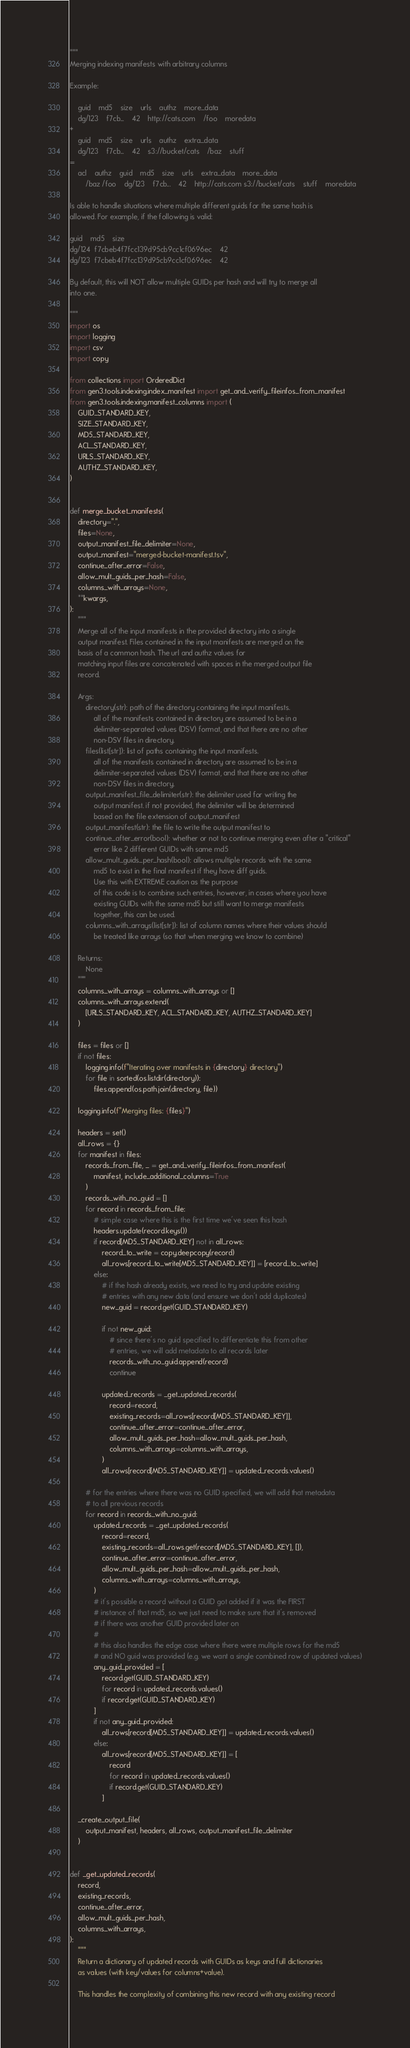<code> <loc_0><loc_0><loc_500><loc_500><_Python_>"""
Merging indexing manifests with arbitrary columns

Example:

    guid    md5    size    urls    authz    more_data
    dg/123    f7cb...    42    http://cats.com    /foo    moredata
+
    guid    md5    size    urls    authz    extra_data
    dg/123    f7cb...    42    s3://bucket/cats    /baz    stuff
=
    acl    authz    guid    md5    size    urls    extra_data    more_data
        /baz /foo    dg/123    f7cb...    42    http://cats.com s3://bucket/cats    stuff    moredata

Is able to handle situations where multiple different guids for the same hash is
allowed. For example, if the following is valid:

guid    md5    size
dg/124  f7cbeb4f7fcc139d95cb9cc1cf0696ec    42
dg/123  f7cbeb4f7fcc139d95cb9cc1cf0696ec    42

By default, this will NOT allow multiple GUIDs per hash and will try to merge all
into one.

"""
import os
import logging
import csv
import copy

from collections import OrderedDict
from gen3.tools.indexing.index_manifest import get_and_verify_fileinfos_from_manifest
from gen3.tools.indexing.manifest_columns import (
    GUID_STANDARD_KEY,
    SIZE_STANDARD_KEY,
    MD5_STANDARD_KEY,
    ACL_STANDARD_KEY,
    URLS_STANDARD_KEY,
    AUTHZ_STANDARD_KEY,
)


def merge_bucket_manifests(
    directory=".",
    files=None,
    output_manifest_file_delimiter=None,
    output_manifest="merged-bucket-manifest.tsv",
    continue_after_error=False,
    allow_mult_guids_per_hash=False,
    columns_with_arrays=None,
    **kwargs,
):
    """
    Merge all of the input manifests in the provided directory into a single
    output manifest. Files contained in the input manifests are merged on the
    basis of a common hash. The url and authz values for
    matching input files are concatenated with spaces in the merged output file
    record.

    Args:
        directory(str): path of the directory containing the input manifests.
            all of the manifests contained in directory are assumed to be in a
            delimiter-separated values (DSV) format, and that there are no other
            non-DSV files in directory.
        files(list[str]): list of paths containing the input manifests.
            all of the manifests contained in directory are assumed to be in a
            delimiter-separated values (DSV) format, and that there are no other
            non-DSV files in directory.
        output_manifest_file_delimiter(str): the delimiter used for writing the
            output manifest. if not provided, the delimiter will be determined
            based on the file extension of output_manifest
        output_manifest(str): the file to write the output manifest to
        continue_after_error(bool): whether or not to continue merging even after a "critical"
            error like 2 different GUIDs with same md5
        allow_mult_guids_per_hash(bool): allows multiple records with the same
            md5 to exist in the final manifest if they have diff guids.
            Use this with EXTREME caution as the purpose
            of this code is to combine such entries, however, in cases where you have
            existing GUIDs with the same md5 but still want to merge manifests
            together, this can be used.
        columns_with_arrays(list[str]): list of column names where their values should
            be treated like arrays (so that when merging we know to combine)

    Returns:
        None
    """
    columns_with_arrays = columns_with_arrays or []
    columns_with_arrays.extend(
        [URLS_STANDARD_KEY, ACL_STANDARD_KEY, AUTHZ_STANDARD_KEY]
    )

    files = files or []
    if not files:
        logging.info(f"Iterating over manifests in {directory} directory")
        for file in sorted(os.listdir(directory)):
            files.append(os.path.join(directory, file))

    logging.info(f"Merging files: {files}")

    headers = set()
    all_rows = {}
    for manifest in files:
        records_from_file, _ = get_and_verify_fileinfos_from_manifest(
            manifest, include_additional_columns=True
        )
        records_with_no_guid = []
        for record in records_from_file:
            # simple case where this is the first time we've seen this hash
            headers.update(record.keys())
            if record[MD5_STANDARD_KEY] not in all_rows:
                record_to_write = copy.deepcopy(record)
                all_rows[record_to_write[MD5_STANDARD_KEY]] = [record_to_write]
            else:
                # if the hash already exists, we need to try and update existing
                # entries with any new data (and ensure we don't add duplicates)
                new_guid = record.get(GUID_STANDARD_KEY)

                if not new_guid:
                    # since there's no guid specified to differentiate this from other
                    # entries, we will add metadata to all records later
                    records_with_no_guid.append(record)
                    continue

                updated_records = _get_updated_records(
                    record=record,
                    existing_records=all_rows[record[MD5_STANDARD_KEY]],
                    continue_after_error=continue_after_error,
                    allow_mult_guids_per_hash=allow_mult_guids_per_hash,
                    columns_with_arrays=columns_with_arrays,
                )
                all_rows[record[MD5_STANDARD_KEY]] = updated_records.values()

        # for the entries where there was no GUID specified, we will add that metadata
        # to all previous records
        for record in records_with_no_guid:
            updated_records = _get_updated_records(
                record=record,
                existing_records=all_rows.get(record[MD5_STANDARD_KEY], []),
                continue_after_error=continue_after_error,
                allow_mult_guids_per_hash=allow_mult_guids_per_hash,
                columns_with_arrays=columns_with_arrays,
            )
            # it's possible a record without a GUID got added if it was the FIRST
            # instance of that md5, so we just need to make sure that it's removed
            # if there was another GUID provided later on
            #
            # this also handles the edge case where there were multiple rows for the md5
            # and NO guid was provided (e.g. we want a single combined row of updated values)
            any_guid_provided = [
                record.get(GUID_STANDARD_KEY)
                for record in updated_records.values()
                if record.get(GUID_STANDARD_KEY)
            ]
            if not any_guid_provided:
                all_rows[record[MD5_STANDARD_KEY]] = updated_records.values()
            else:
                all_rows[record[MD5_STANDARD_KEY]] = [
                    record
                    for record in updated_records.values()
                    if record.get(GUID_STANDARD_KEY)
                ]

    _create_output_file(
        output_manifest, headers, all_rows, output_manifest_file_delimiter
    )


def _get_updated_records(
    record,
    existing_records,
    continue_after_error,
    allow_mult_guids_per_hash,
    columns_with_arrays,
):
    """
    Return a dictionary of updated records with GUIDs as keys and full dictionaries
    as values (with key/values for columns+value).

    This handles the complexity of combining this new record with any existing record</code> 